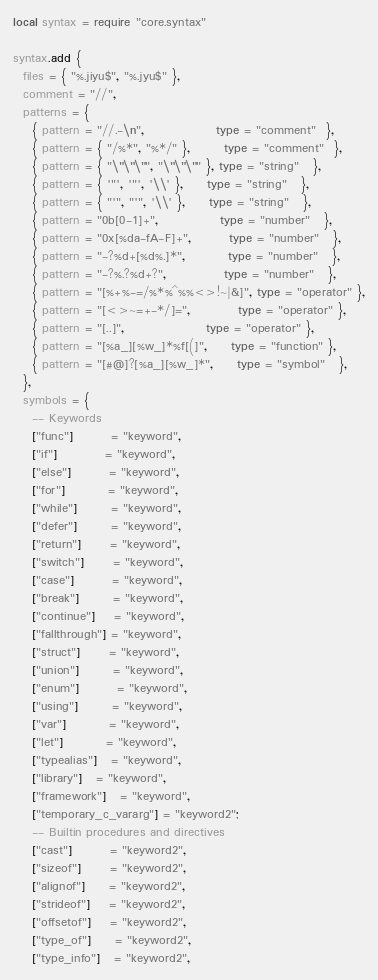Convert code to text. <code><loc_0><loc_0><loc_500><loc_500><_Lua_>local syntax = require "core.syntax"

syntax.add {
  files = { "%.jiyu$", "%.jyu$" },
  comment = "//",
  patterns = {
    { pattern = "//.-\n",               type = "comment"  },
    { pattern = { "/%*", "%*/" },       type = "comment"  },
    { pattern = { "\"\"\"", "\"\"\"" }, type = "string"   },
    { pattern = { '"', '"', '\\' },     type = "string"   },
    { pattern = { "'", "'", '\\' },     type = "string"   },
    { pattern = "0b[0-1]+",             type = "number"   },
    { pattern = "0x[%da-fA-F]+",        type = "number"   },
    { pattern = "-?%d+[%d%.]*",         type = "number"   },
    { pattern = "-?%.?%d+?",            type = "number"   },
    { pattern = "[%+%-=/%*%^%%<>!~|&]", type = "operator" },
    { pattern = "[<>~=+-*/]=",          type = "operator" },
    { pattern = "[..]",                 type = "operator" },
    { pattern = "[%a_][%w_]*%f[(]",     type = "function" },
    { pattern = "[#@]?[%a_][%w_]*",     type = "symbol"   },
  },
  symbols = {
    -- Keywords
    ["func"]        = "keyword",
    ["if"]          = "keyword",
    ["else"]        = "keyword",
    ["for"]         = "keyword",
    ["while"]       = "keyword",
    ["defer"]       = "keyword",
    ["return"]      = "keyword",
    ["switch"]      = "keyword",
    ["case"]        = "keyword",
    ["break"]       = "keyword",
    ["continue"]    = "keyword",
    ["fallthrough"] = "keyword",
    ["struct"]      = "keyword",
    ["union"]       = "keyword",
    ["enum"]        = "keyword",
    ["using"]       = "keyword",
    ["var"]         = "keyword",
    ["let"]         = "keyword",
    ["typealias"]   = "keyword",
    ["library"]   = "keyword",
    ["framework"]   = "keyword",
    ["temporary_c_vararg"] = "keyword2";
    -- Builtin procedures and directives
    ["cast"]        = "keyword2",
    ["sizeof"]      = "keyword2",
    ["alignof"]     = "keyword2",
    ["strideof"]    = "keyword2",
    ["offsetof"]    = "keyword2",
    ["type_of"]     = "keyword2",
    ["type_info"]   = "keyword2",</code> 